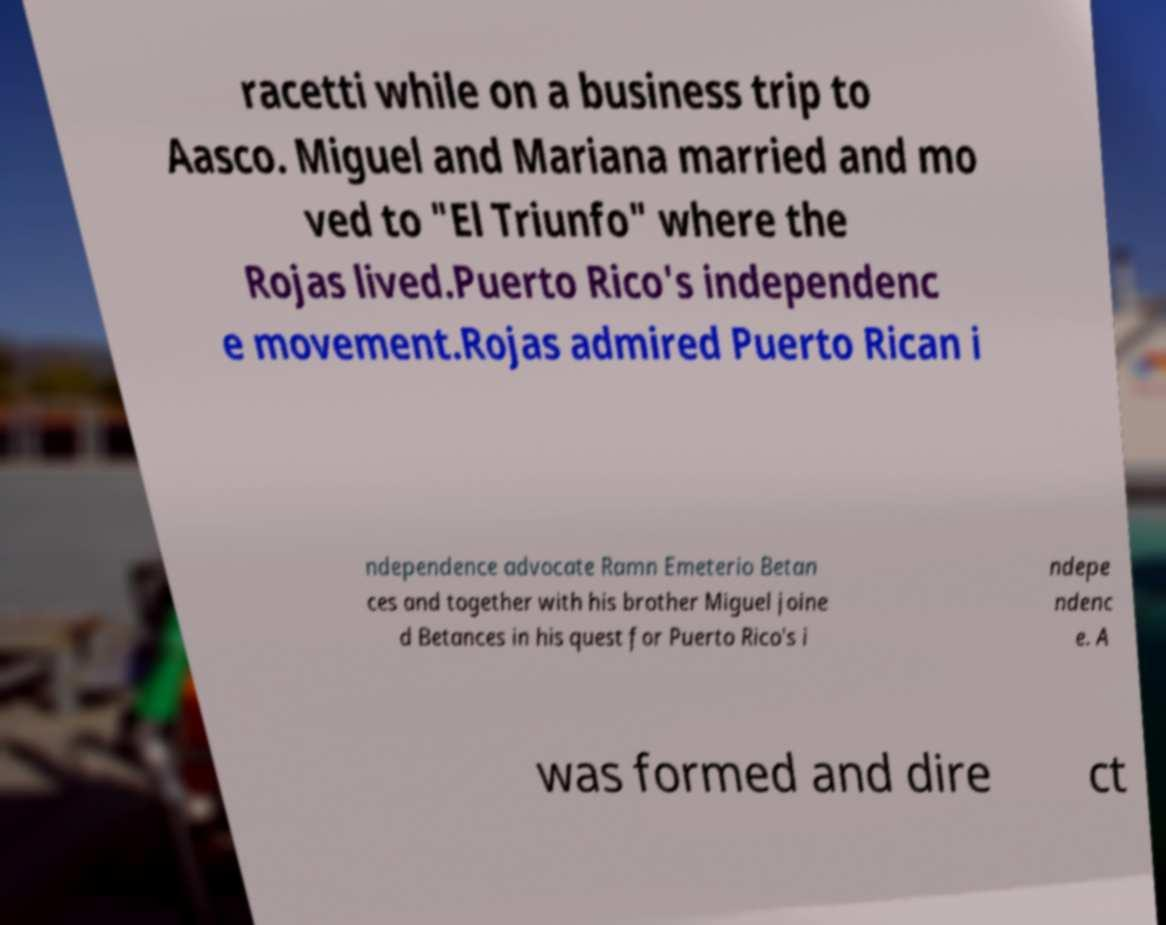Could you extract and type out the text from this image? racetti while on a business trip to Aasco. Miguel and Mariana married and mo ved to "El Triunfo" where the Rojas lived.Puerto Rico's independenc e movement.Rojas admired Puerto Rican i ndependence advocate Ramn Emeterio Betan ces and together with his brother Miguel joine d Betances in his quest for Puerto Rico's i ndepe ndenc e. A was formed and dire ct 